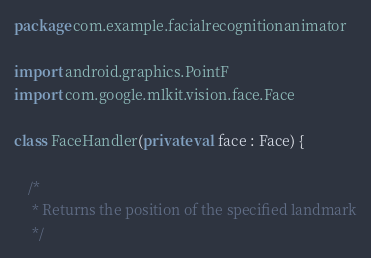<code> <loc_0><loc_0><loc_500><loc_500><_Kotlin_>package com.example.facialrecognitionanimator

import android.graphics.PointF
import com.google.mlkit.vision.face.Face

class FaceHandler(private val face : Face) {

    /*
     * Returns the position of the specified landmark
     */</code> 